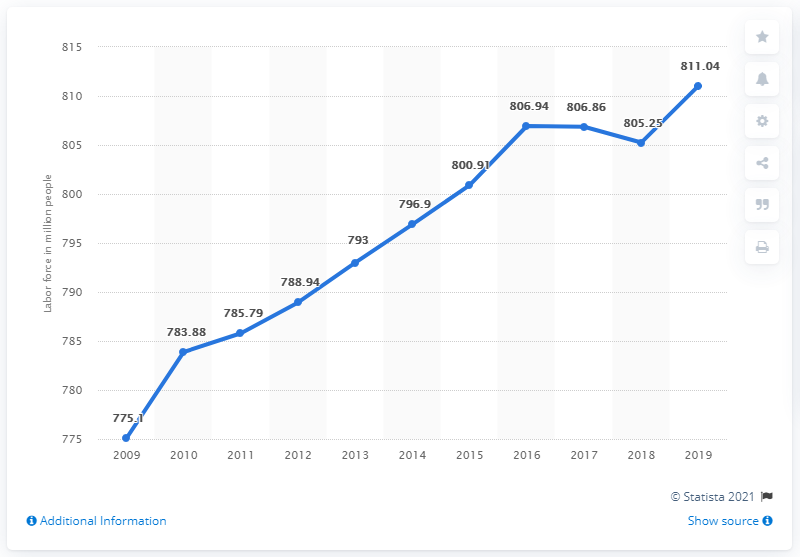Mention a couple of crucial points in this snapshot. In 2019, China's labor force was estimated to be 811.04 million people. 